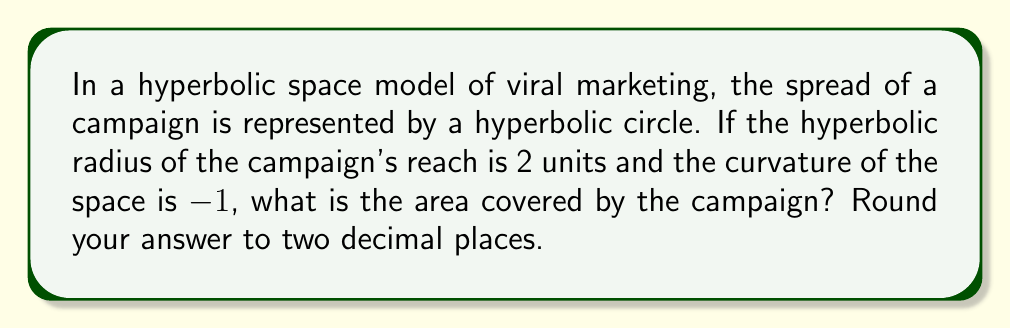Can you answer this question? To solve this problem, we'll use the formula for the area of a circle in hyperbolic geometry:

1) The area of a hyperbolic circle is given by:
   $$A = 4\pi \sinh^2(\frac{r}{2})$$
   Where $r$ is the hyperbolic radius and $\sinh$ is the hyperbolic sine function.

2) We're given that $r = 2$ and the curvature $K = -1$.

3) Substitute $r = 2$ into the formula:
   $$A = 4\pi \sinh^2(\frac{2}{2}) = 4\pi \sinh^2(1)$$

4) Calculate $\sinh(1)$:
   $$\sinh(1) = \frac{e^1 - e^{-1}}{2} \approx 1.1752$$

5) Square this value:
   $$\sinh^2(1) \approx (1.1752)^2 \approx 1.3811$$

6) Multiply by $4\pi$:
   $$A \approx 4\pi(1.3811) \approx 17.3375$$

7) Round to two decimal places:
   $$A \approx 17.34$$

Therefore, the area covered by the campaign in this hyperbolic space is approximately 17.34 square units.
Answer: 17.34 square units 